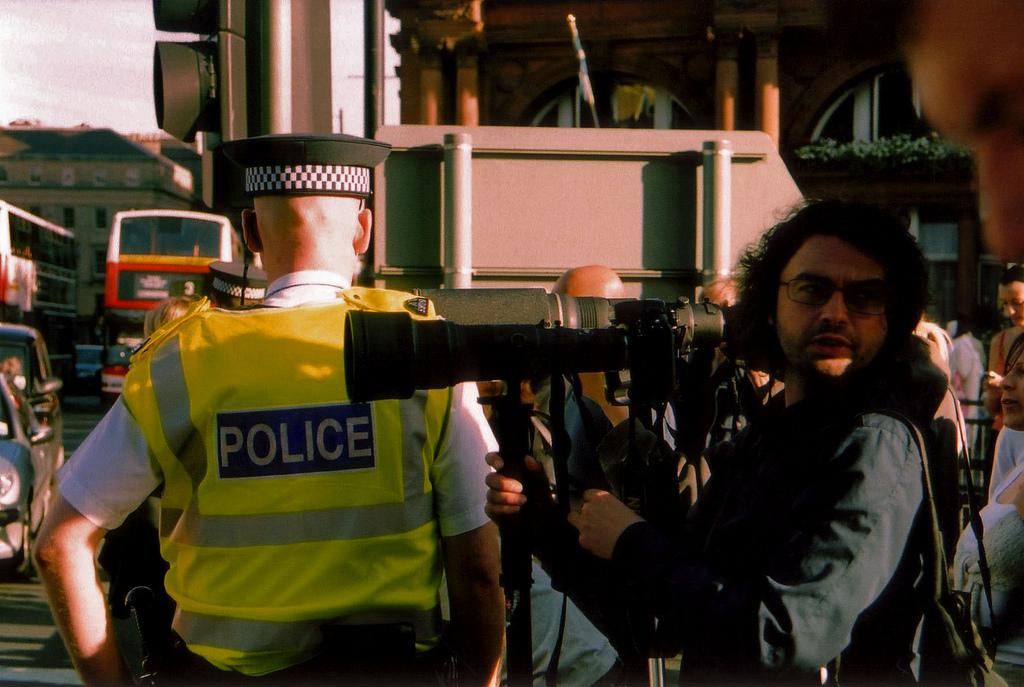Question: who is wearing a hat with a checkered pattern border?
Choices:
A. The guard.
B. The police officer.
C. The teacher.
D. The lawyer.
Answer with the letter. Answer: B Question: what is the man in the blue jacket holding?
Choices:
A. A cell phone.
B. A camera.
C. An umbrella.
D. A banjo.
Answer with the letter. Answer: B Question: what is the police officer wearing on his head?
Choices:
A. A toupee.
B. A hat.
C. A stocking cap.
D. A helmet.
Answer with the letter. Answer: B Question: when is this taken?
Choices:
A. When you have an infection.
B. When you have heartburn.
C. After something that's a big deal happened.
D. When you have a headache.
Answer with the letter. Answer: C Question: what color is the police officers vest?
Choices:
A. Orange.
B. Neon yellow.
C. Red.
D. Blue.
Answer with the letter. Answer: B Question: who wearing the yellow vest?
Choices:
A. The police officer.
B. The fireman.
C. The logger.
D. The road worker.
Answer with the letter. Answer: A Question: where is the photo taken?
Choices:
A. In a movie lot in Hollywood.
B. At a t photo-shoot in a metro area.
C. Next to the Hollywood Sign, Hollywood.
D. In Griffith Park, Hollywood.
Answer with the letter. Answer: B Question: who is wearing a short sleeved shirt?
Choices:
A. The bicycle rider.
B. The policeman.
C. The postal worker.
D. The landscaper.
Answer with the letter. Answer: B Question: what is in front of the policemen?
Choices:
A. Three pedestrians.
B. Christmas shoppers.
C. A double decker bus.
D. A Roto Rooter van making a left turn.
Answer with the letter. Answer: C Question: what is cameraman carrying on his left shoulder?
Choices:
A. A camera.
B. A light.
C. Nothing.
D. A bag.
Answer with the letter. Answer: D Question: how is the man's lens propped up?
Choices:
A. On his hand.
B. On the wall.
C. By someone else.
D. On a stick.
Answer with the letter. Answer: D Question: where is the camera pointing?
Choices:
A. At the crowd.
B. Atthe sky.
C. At the herd of cows.
D. At the back of a police officer.
Answer with the letter. Answer: D Question: who is wearing glasses?
Choices:
A. The reporter.
B. The firefighter.
C. The chief.
D. The cameraman.
Answer with the letter. Answer: D Question: where is the cameraman standing?
Choices:
A. On the second floor balcony.
B. Behind the policeman.
C. In the median.
D. At the top of the stairs.
Answer with the letter. Answer: B Question: who is wearing a black and white hat?
Choices:
A. The child.
B. The horse.
C. The policeman.
D. No one.
Answer with the letter. Answer: C Question: who is wearing a white shirt?
Choices:
A. The policeman.
B. A child.
C. Everyone.
D. No one.
Answer with the letter. Answer: A 